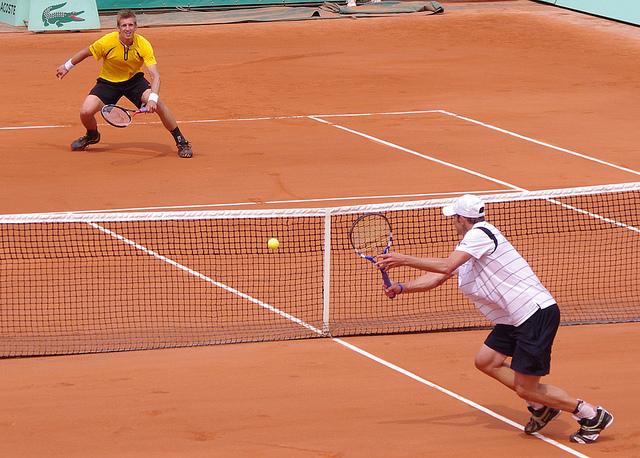Is the net trying to eat the tennis ball?
Short answer required. No. What color is the court?
Short answer required. Orange. Is the ball in motion?
Concise answer only. Yes. 